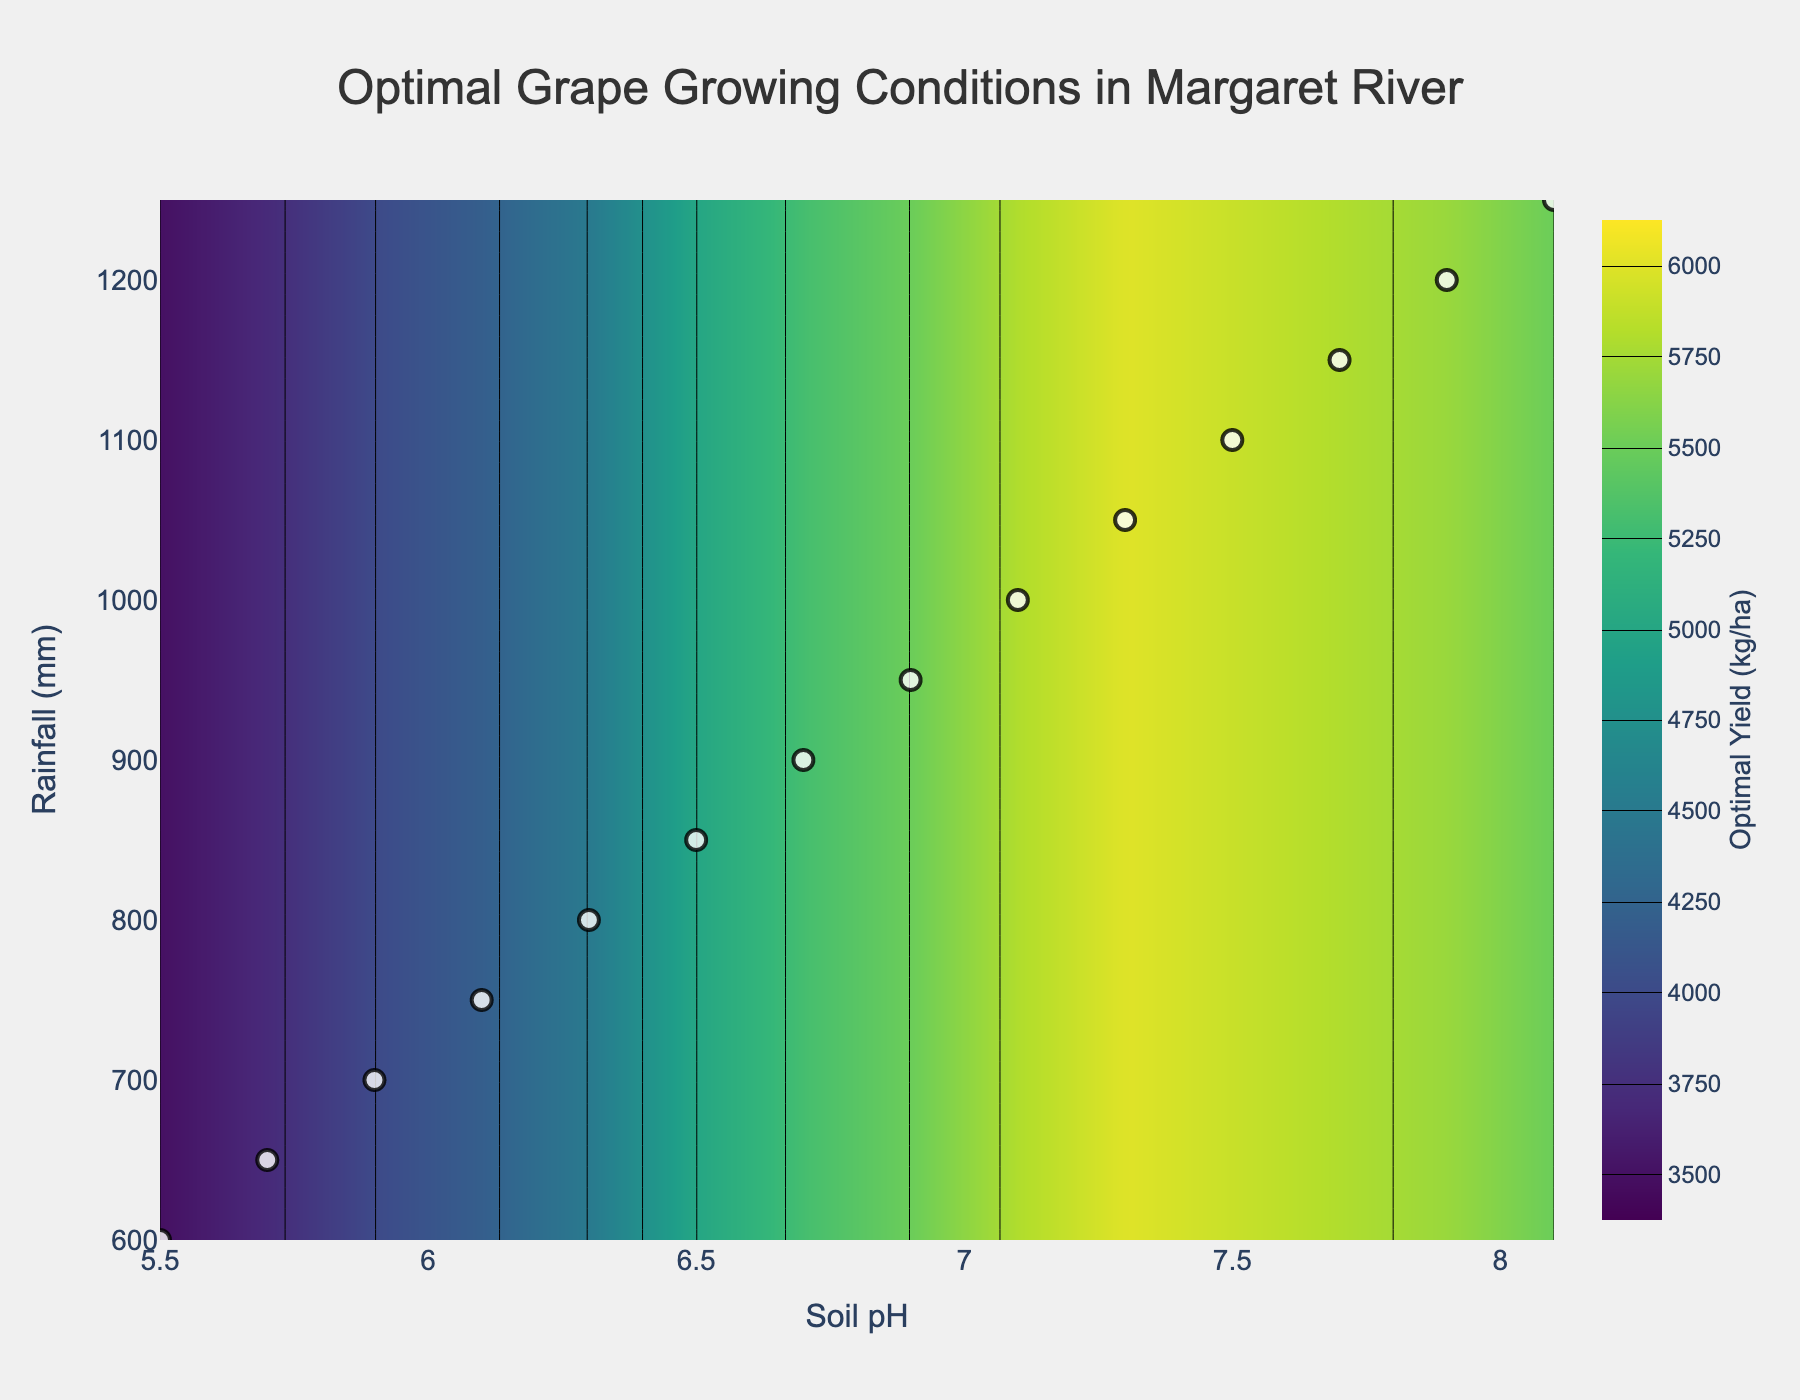What is the title of the figure? The title of the figure is usually displayed at the top center part of the chart. In this figure, it reads "Optimal Grape Growing Conditions in Margaret River".
Answer: Optimal Grape Growing Conditions in Margaret River What are the units of the x-axis? The x-axis represents Soil pH, which is a measure of acidity or alkalinity of the soil. Therefore, the units are pH.
Answer: pH How many data points are represented in the figure? The figure includes data points as markers on the scatter plot. The number of distinct markers corresponds to the number of data points, which can be counted. In this case, there are 14 data points.
Answer: 14 Which Soil pH and Rainfall combination yields the highest optimal yield? By observing the contour plot and the accompanying data points, the highest optimal yield is 6000 kg/ha, which corresponds to a Soil pH of 7.3 and Rainfall of 1050 mm.
Answer: Soil pH 7.3, Rainfall 1050 mm At what Soil pH and Rainfall does the optimal yield first reach 5000 kg/ha? Examining the contour intervals and data points, 5000 kg/ha yield is first reached at Soil pH of 6.5 and Rainfall of 850 mm.
Answer: Soil pH 6.5, Rainfall 850 mm Compare the optimal yields for Rainfall levels of 900 mm and 1200 mm. Which is higher? Looking at the contour lines and data points, for Rainfall of 900 mm, the yield is 5300 kg/ha. For Rainfall of 1200 mm, the yield is 5700 kg/ha. Therefore, the yield at 1200 mm Rainfall is higher.
Answer: 1200 mm What happens to the optimal yield as Soil pH increases from 5.5 to 7.3 at constant Rainfall of 1050 mm? Observing the contour plot from Soil pH 5.5 to 7.3 while maintaining Rainfall at 1050 mm, the optimal yield generally increases. At 7.3 it reaches its peak of 6000 kg/ha.
Answer: Increases Describe the range of the Soil pH axis on the contour plot. The range of the Soil pH axis can be read directly from the axis labels. The x-axis starts at 5.5 and ends at 8.1.
Answer: 5.5 to 8.1 What is the contour interval for the yield in kg/ha? The contour plot represents yield values with distinct color bands. The difference between each contour line, as specified in the code, is 250 kg/ha.
Answer: 250 kg/ha Is the relationship between Soil pH and optimal yield more significant than between Rainfall and optimal yield? By observing the contour plot, the yield seems to vary more consistently and significantly with Rainfall compared to Soil pH. Thus, the relationship between Rainfall and optimal yield appears more significant.
Answer: Rainfall 